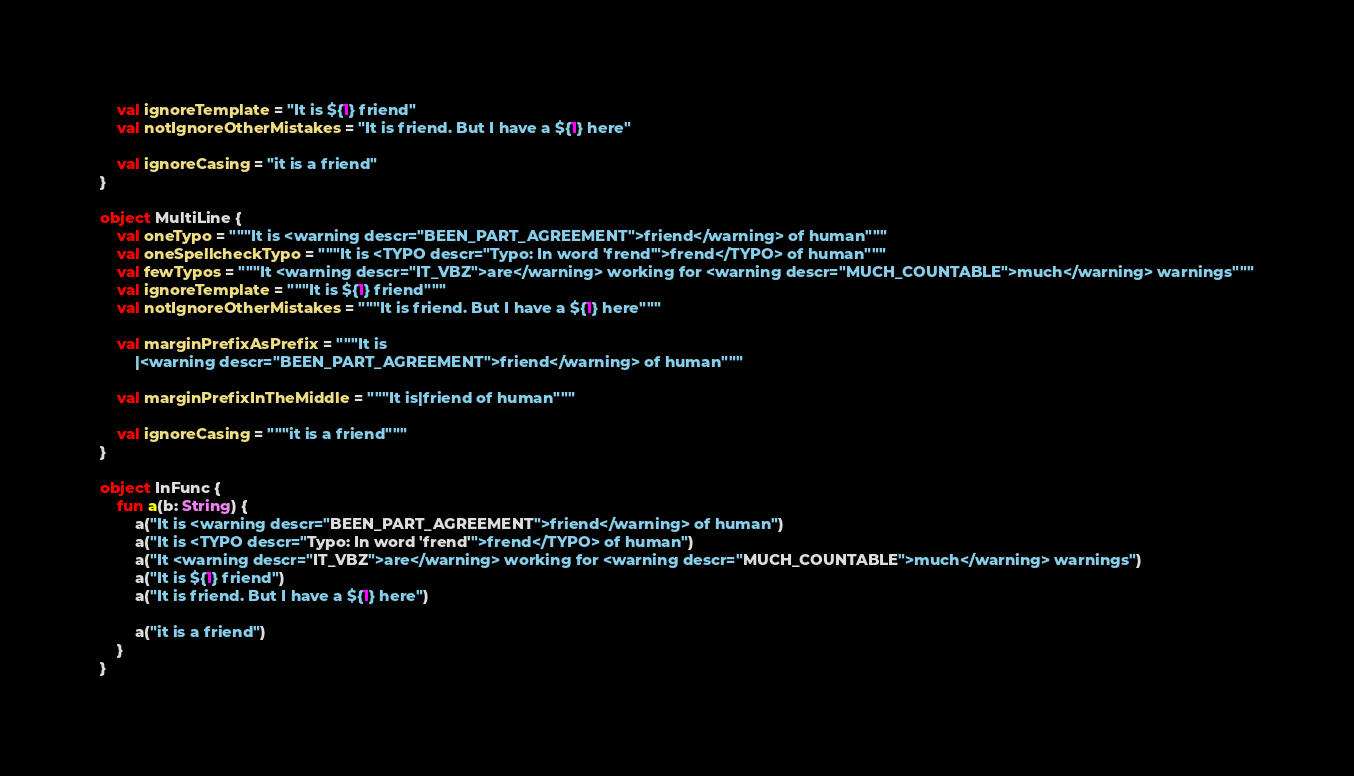<code> <loc_0><loc_0><loc_500><loc_500><_Kotlin_>    val ignoreTemplate = "It is ${1} friend"
    val notIgnoreOtherMistakes = "It is friend. But I have a ${1} here"

    val ignoreCasing = "it is a friend"
}

object MultiLine {
    val oneTypo = """It is <warning descr="BEEN_PART_AGREEMENT">friend</warning> of human"""
    val oneSpellcheckTypo = """It is <TYPO descr="Typo: In word 'frend'">frend</TYPO> of human"""
    val fewTypos = """It <warning descr="IT_VBZ">are</warning> working for <warning descr="MUCH_COUNTABLE">much</warning> warnings"""
    val ignoreTemplate = """It is ${1} friend"""
    val notIgnoreOtherMistakes = """It is friend. But I have a ${1} here"""

    val marginPrefixAsPrefix = """It is 
        |<warning descr="BEEN_PART_AGREEMENT">friend</warning> of human"""

    val marginPrefixInTheMiddle = """It is|friend of human"""

    val ignoreCasing = """it is a friend"""
}

object InFunc {
    fun a(b: String) {
        a("It is <warning descr="BEEN_PART_AGREEMENT">friend</warning> of human")
        a("It is <TYPO descr="Typo: In word 'frend'">frend</TYPO> of human")
        a("It <warning descr="IT_VBZ">are</warning> working for <warning descr="MUCH_COUNTABLE">much</warning> warnings")
        a("It is ${1} friend")
        a("It is friend. But I have a ${1} here")

        a("it is a friend")
    }
}

</code> 